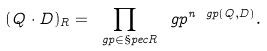<formula> <loc_0><loc_0><loc_500><loc_500>( Q \cdot D ) _ { R } = \prod _ { \ g p \in \S p e c R } \ g p ^ { n _ { \ } g p ( Q , D ) } .</formula> 